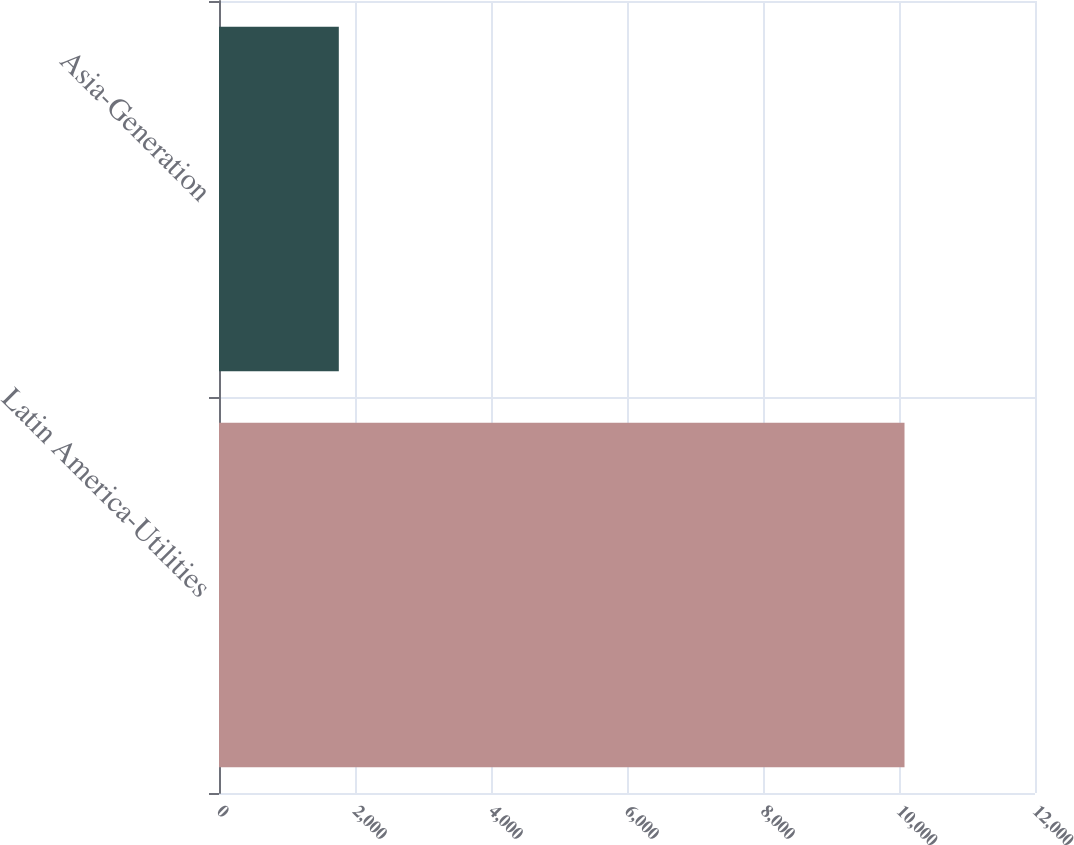<chart> <loc_0><loc_0><loc_500><loc_500><bar_chart><fcel>Latin America-Utilities<fcel>Asia-Generation<nl><fcel>10081<fcel>1762<nl></chart> 